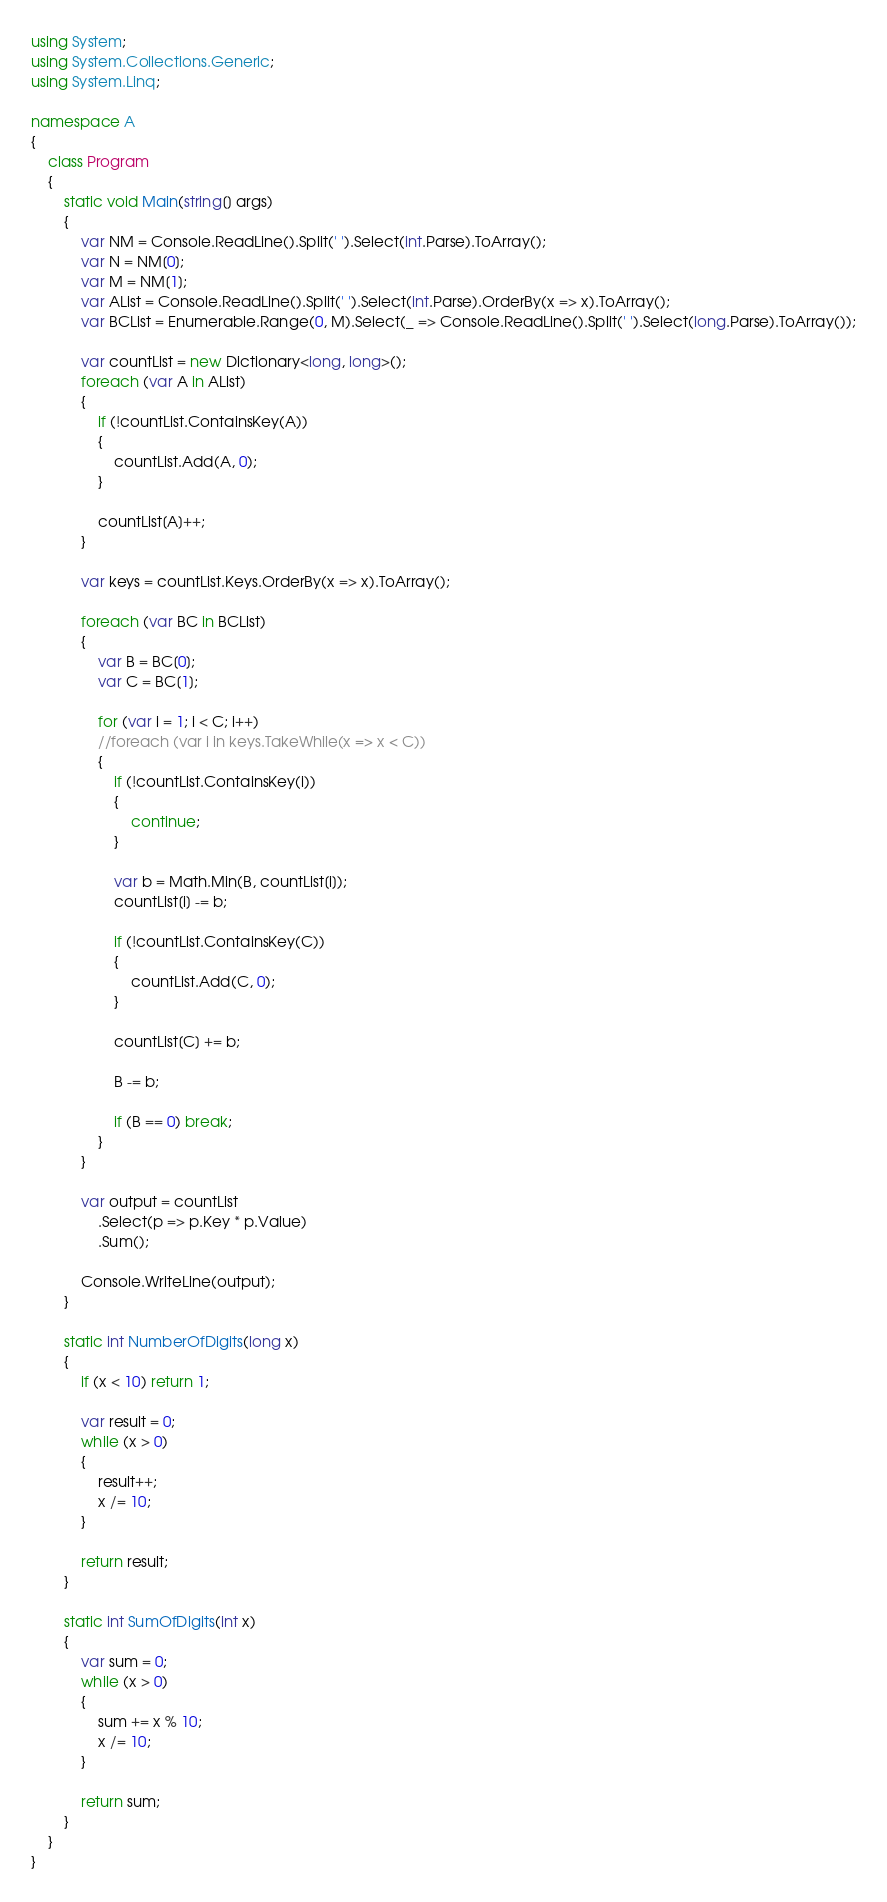<code> <loc_0><loc_0><loc_500><loc_500><_C#_>using System;
using System.Collections.Generic;
using System.Linq;

namespace A
{
    class Program
    {
        static void Main(string[] args)
        {
            var NM = Console.ReadLine().Split(' ').Select(int.Parse).ToArray();
            var N = NM[0];
            var M = NM[1];
            var AList = Console.ReadLine().Split(' ').Select(int.Parse).OrderBy(x => x).ToArray();
            var BCList = Enumerable.Range(0, M).Select(_ => Console.ReadLine().Split(' ').Select(long.Parse).ToArray());

            var countList = new Dictionary<long, long>();
            foreach (var A in AList)
            {
                if (!countList.ContainsKey(A))
                {
                    countList.Add(A, 0);
                }

                countList[A]++;
            }

            var keys = countList.Keys.OrderBy(x => x).ToArray();

            foreach (var BC in BCList)
            {
                var B = BC[0];
                var C = BC[1];

                for (var i = 1; i < C; i++)
                //foreach (var i in keys.TakeWhile(x => x < C))
                {
                    if (!countList.ContainsKey(i))
                    {
                        continue;
                    }

                    var b = Math.Min(B, countList[i]);
                    countList[i] -= b;

                    if (!countList.ContainsKey(C))
                    {
                        countList.Add(C, 0);
                    }

                    countList[C] += b;

                    B -= b;

                    if (B == 0) break;
                }
            }

            var output = countList
                .Select(p => p.Key * p.Value)
                .Sum();

            Console.WriteLine(output);
        }

        static int NumberOfDigits(long x)
        {
            if (x < 10) return 1;

            var result = 0;
            while (x > 0)
            {
                result++;
                x /= 10;
            }

            return result;
        }

        static int SumOfDigits(int x)
        {
            var sum = 0;
            while (x > 0)
            {
                sum += x % 10;
                x /= 10;
            }

            return sum;
        }
    }
}
</code> 